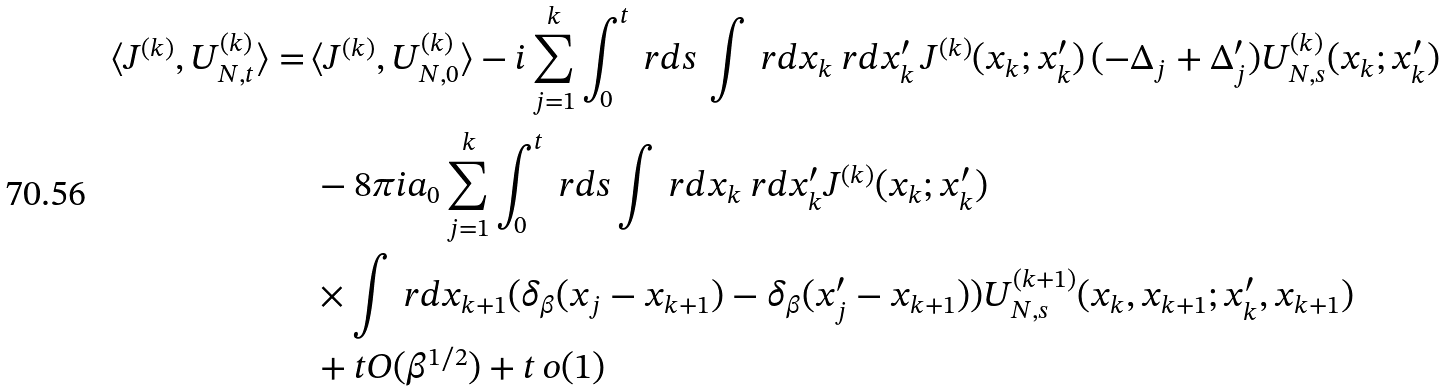<formula> <loc_0><loc_0><loc_500><loc_500>\langle J ^ { ( k ) } , U _ { N , t } ^ { ( k ) } \rangle = \, & \langle J ^ { ( k ) } , U _ { N , 0 } ^ { ( k ) } \rangle - i \sum _ { j = 1 } ^ { k } \int _ { 0 } ^ { t } \ r d s \, \int \ r d { x } _ { k } \ r d { x } _ { k } ^ { \prime } \, J ^ { ( k ) } ( { x } _ { k } ; { x } _ { k } ^ { \prime } ) \, ( - \Delta _ { j } + \Delta _ { j } ^ { \prime } ) U ^ { ( k ) } _ { N , s } ( { x } _ { k } ; { x } _ { k } ^ { \prime } ) \\ & - 8 \pi i a _ { 0 } \sum _ { j = 1 } ^ { k } \int _ { 0 } ^ { t } \ r d s \int \ r d { x } _ { k } \ r d { x } _ { k } ^ { \prime } J ^ { ( k ) } ( { x } _ { k } ; { x } _ { k } ^ { \prime } ) \\ & \times \int \ r d x _ { k + 1 } ( \delta _ { \beta } ( x _ { j } - x _ { k + 1 } ) - \delta _ { \beta } ( x _ { j } ^ { \prime } - x _ { k + 1 } ) ) U _ { N , s } ^ { ( k + 1 ) } ( { x } _ { k } , x _ { k + 1 } ; { x } _ { k } ^ { \prime } , x _ { k + 1 } ) \\ & + t O ( \beta ^ { 1 / 2 } ) + t \, o ( 1 )</formula> 